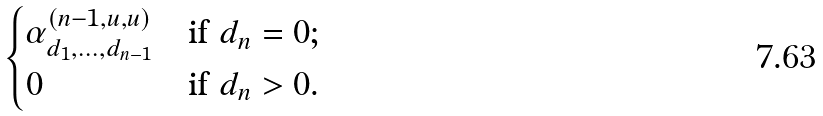<formula> <loc_0><loc_0><loc_500><loc_500>\begin{cases} \alpha ^ { ( n - 1 , u , u ) } _ { d _ { 1 } , \dots , d _ { n - 1 } } & \text {if $d_{n}=0$;} \\ 0 & \text {if $d_{n}>0$.} \end{cases}</formula> 